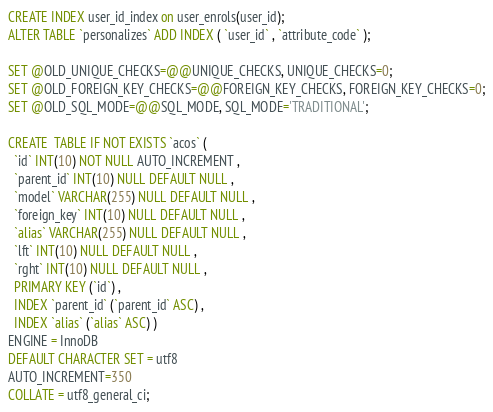Convert code to text. <code><loc_0><loc_0><loc_500><loc_500><_SQL_>CREATE INDEX user_id_index on user_enrols(user_id);
ALTER TABLE `personalizes` ADD INDEX ( `user_id` , `attribute_code` );

SET @OLD_UNIQUE_CHECKS=@@UNIQUE_CHECKS, UNIQUE_CHECKS=0;
SET @OLD_FOREIGN_KEY_CHECKS=@@FOREIGN_KEY_CHECKS, FOREIGN_KEY_CHECKS=0;
SET @OLD_SQL_MODE=@@SQL_MODE, SQL_MODE='TRADITIONAL';

CREATE  TABLE IF NOT EXISTS `acos` (
  `id` INT(10) NOT NULL AUTO_INCREMENT ,
  `parent_id` INT(10) NULL DEFAULT NULL ,
  `model` VARCHAR(255) NULL DEFAULT NULL ,
  `foreign_key` INT(10) NULL DEFAULT NULL ,
  `alias` VARCHAR(255) NULL DEFAULT NULL ,
  `lft` INT(10) NULL DEFAULT NULL ,
  `rght` INT(10) NULL DEFAULT NULL ,
  PRIMARY KEY (`id`) ,
  INDEX `parent_id` (`parent_id` ASC) ,
  INDEX `alias` (`alias` ASC) )
ENGINE = InnoDB
DEFAULT CHARACTER SET = utf8
AUTO_INCREMENT=350
COLLATE = utf8_general_ci;
</code> 